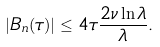Convert formula to latex. <formula><loc_0><loc_0><loc_500><loc_500>\left | B _ { n } ( \tau ) \right | \leq 4 \tau \frac { 2 \nu \ln \lambda } { \lambda } .</formula> 